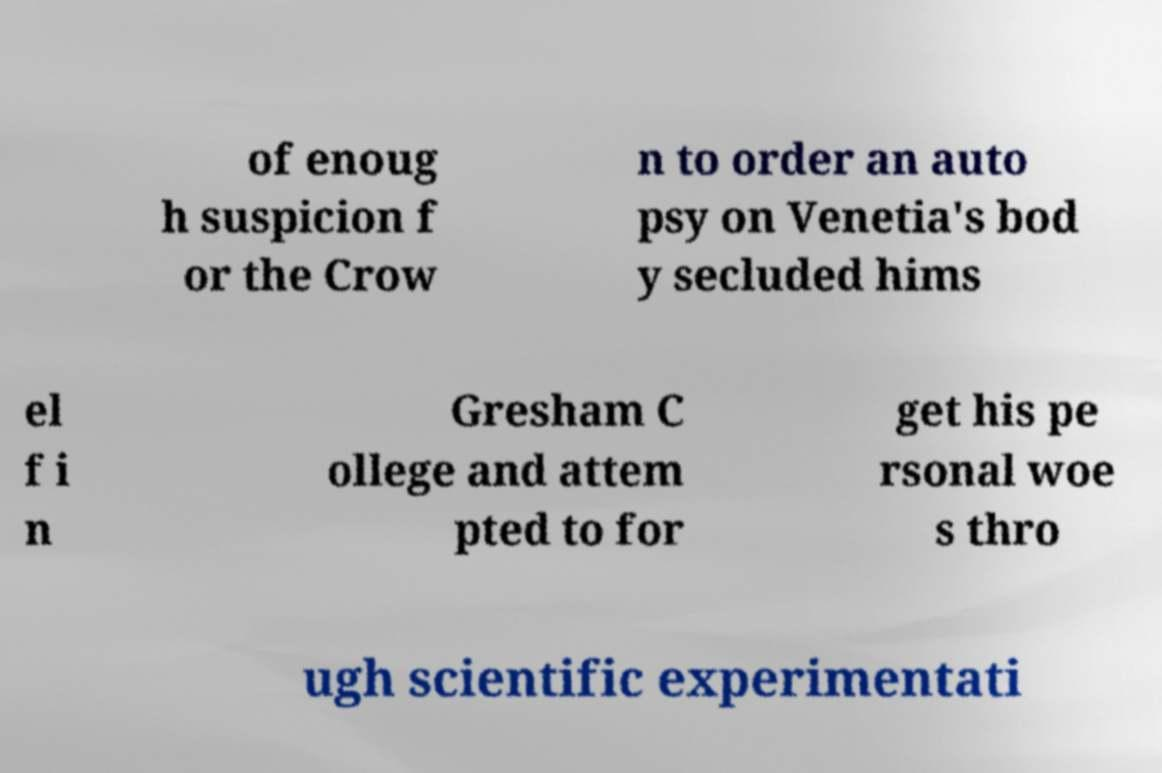Could you assist in decoding the text presented in this image and type it out clearly? of enoug h suspicion f or the Crow n to order an auto psy on Venetia's bod y secluded hims el f i n Gresham C ollege and attem pted to for get his pe rsonal woe s thro ugh scientific experimentati 